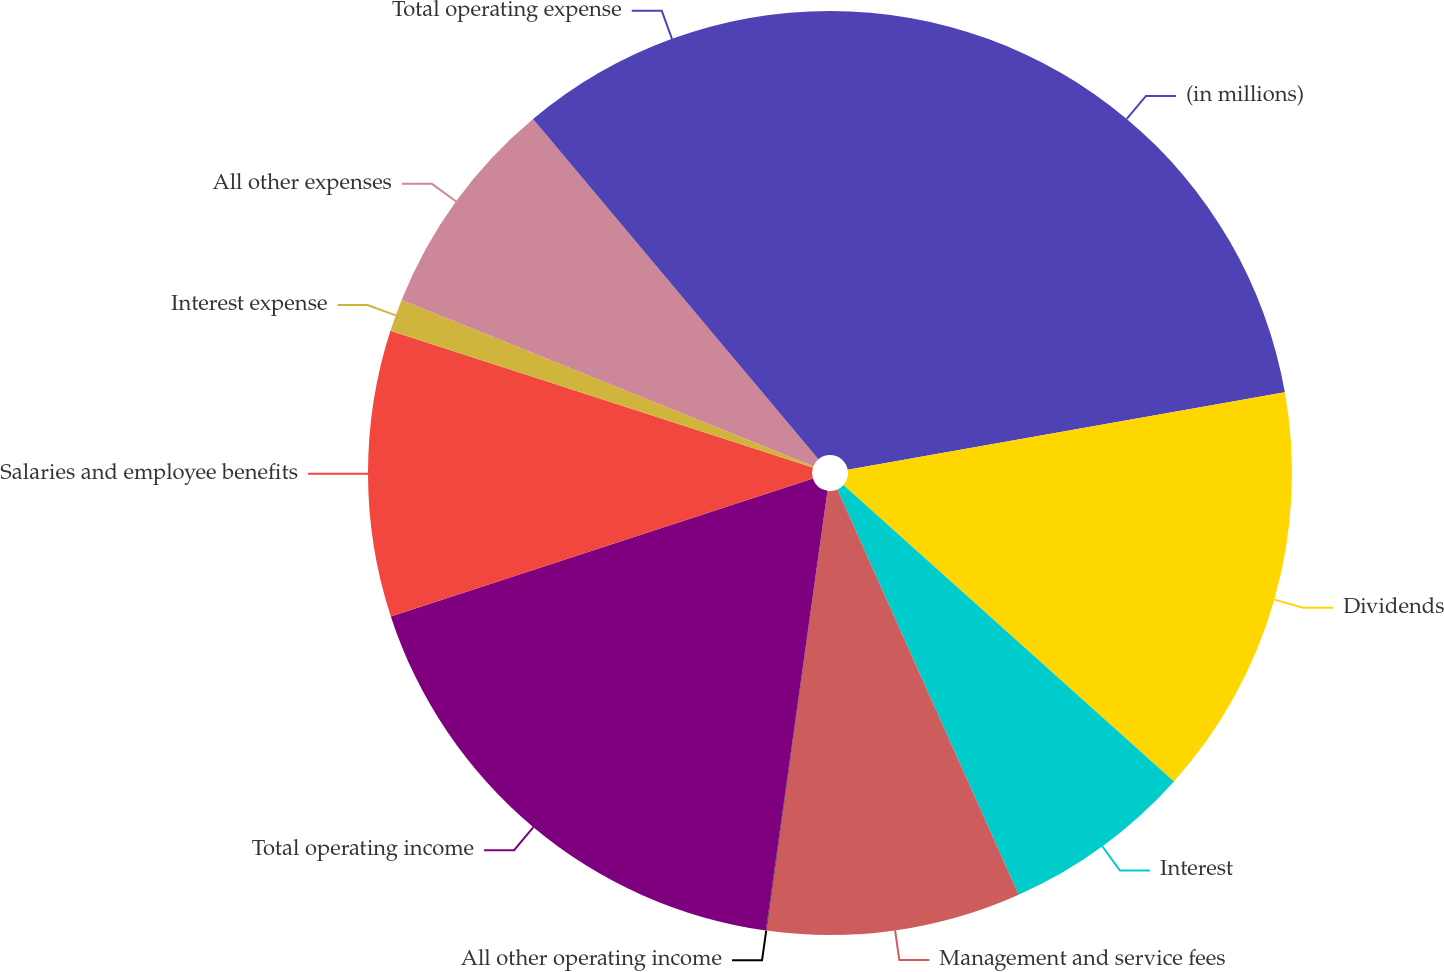Convert chart to OTSL. <chart><loc_0><loc_0><loc_500><loc_500><pie_chart><fcel>(in millions)<fcel>Dividends<fcel>Interest<fcel>Management and service fees<fcel>All other operating income<fcel>Total operating income<fcel>Salaries and employee benefits<fcel>Interest expense<fcel>All other expenses<fcel>Total operating expense<nl><fcel>22.2%<fcel>14.43%<fcel>6.67%<fcel>8.89%<fcel>0.02%<fcel>17.76%<fcel>10.0%<fcel>1.13%<fcel>7.78%<fcel>11.11%<nl></chart> 